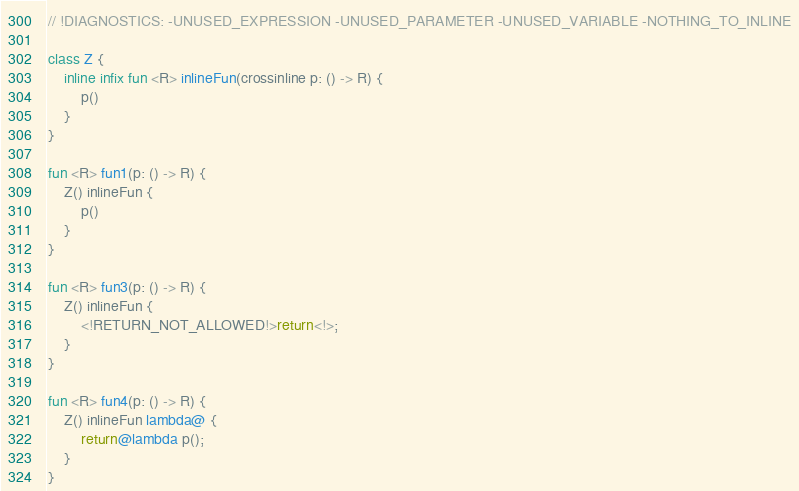Convert code to text. <code><loc_0><loc_0><loc_500><loc_500><_Kotlin_>// !DIAGNOSTICS: -UNUSED_EXPRESSION -UNUSED_PARAMETER -UNUSED_VARIABLE -NOTHING_TO_INLINE

class Z {
    inline infix fun <R> inlineFun(crossinline p: () -> R) {
        p()
    }
}

fun <R> fun1(p: () -> R) {
    Z() inlineFun {
        p()
    }
}

fun <R> fun3(p: () -> R) {
    Z() inlineFun {
        <!RETURN_NOT_ALLOWED!>return<!>;
    }
}

fun <R> fun4(p: () -> R) {
    Z() inlineFun lambda@ {
        return@lambda p();
    }
}
</code> 